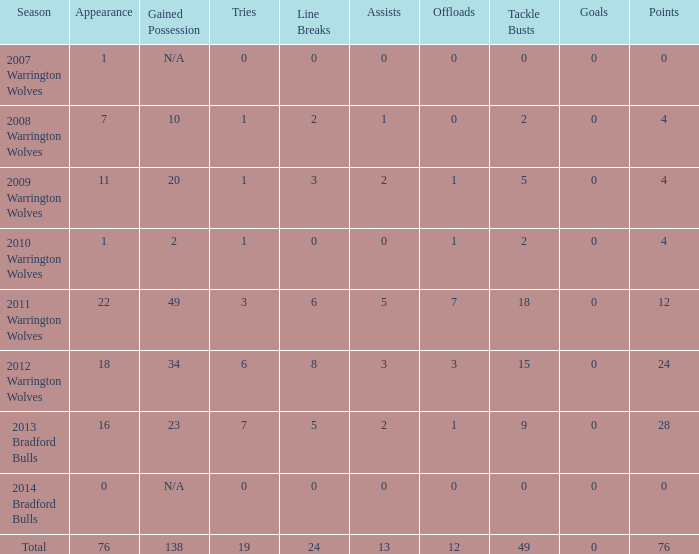What is the average tries for the season 2008 warrington wolves with an appearance more than 7? None. 